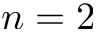Convert formula to latex. <formula><loc_0><loc_0><loc_500><loc_500>n = 2</formula> 